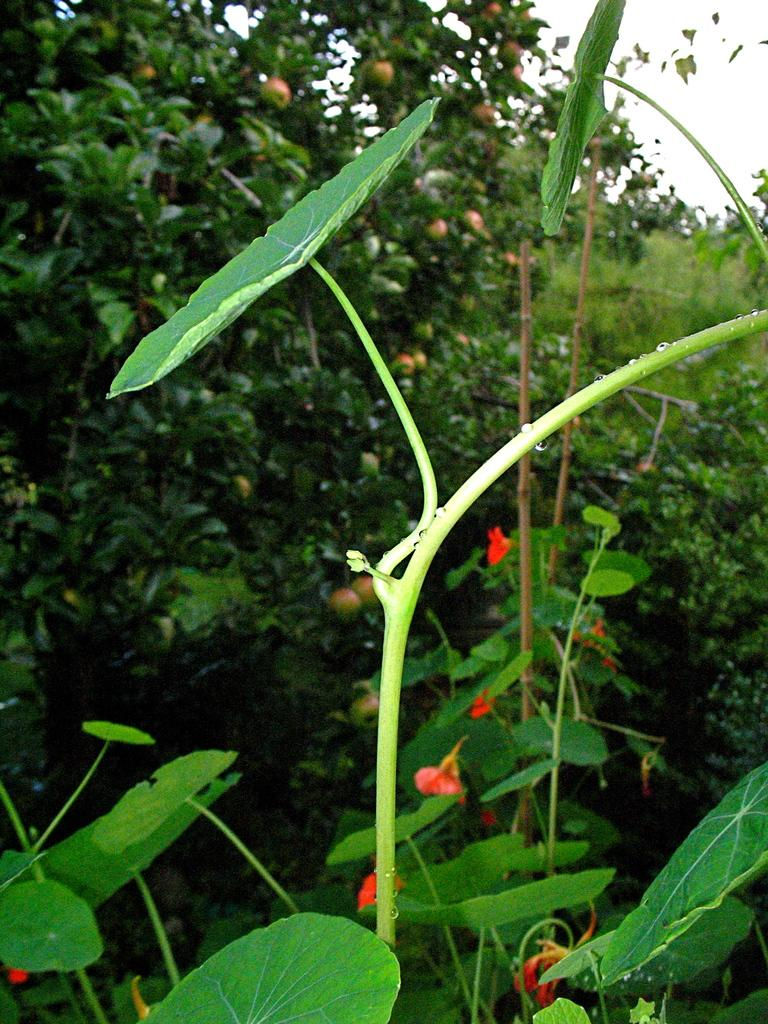What type of vegetation can be seen in the image? There are trees in the image. What else is present in the image besides trees? There are fruits in the image. What can be seen in the background of the image? The sky is visible in the background of the image. What type of cushion is being used topped with celery in the image? There is no cushion or celery present in the image. What religious symbol can be seen in the image? There is no religious symbol present in the image. 